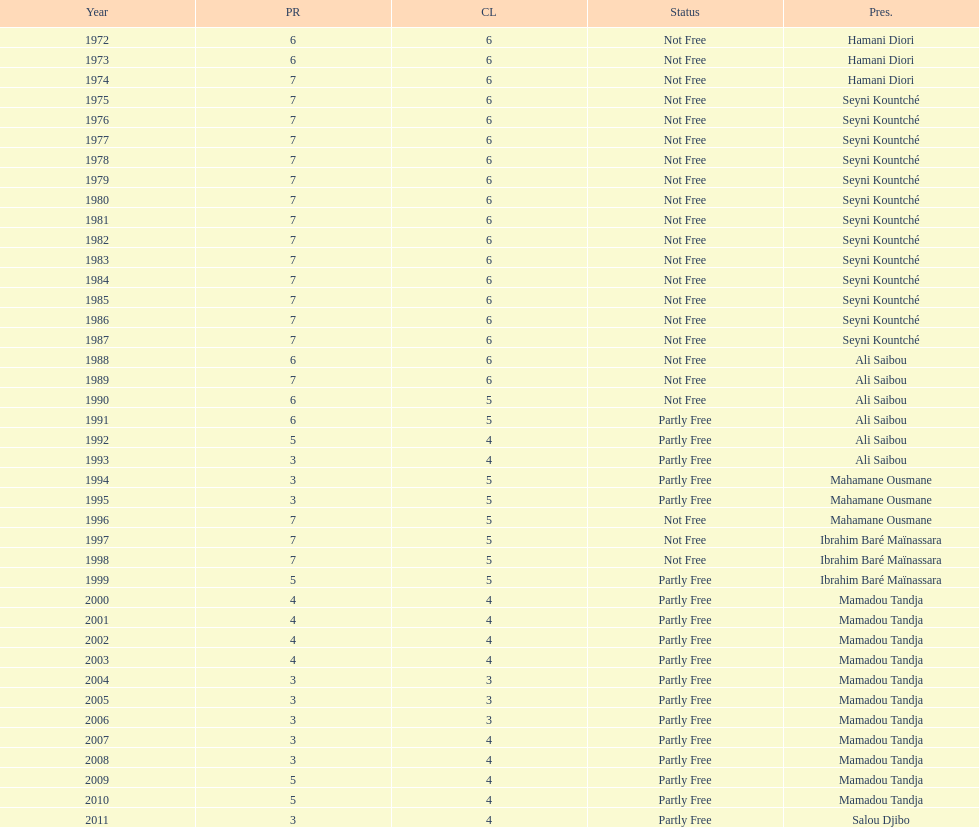Who ruled longer, ali saibou or mamadou tandja? Mamadou Tandja. 